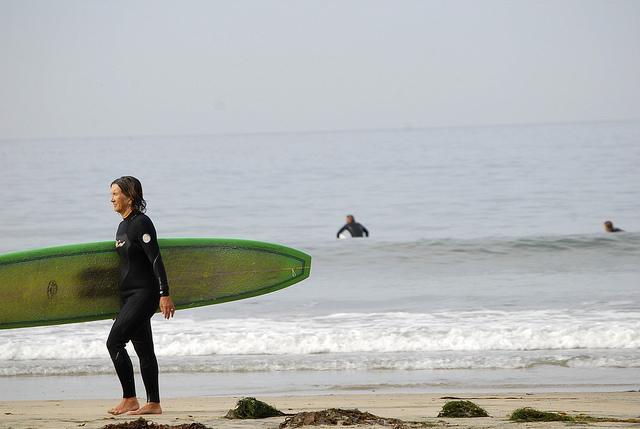Is he surfing right now?
Be succinct. No. Is the woman finished surfing?
Short answer required. Yes. Is the woman wearing shoes?
Concise answer only. No. How many surfers are shown?
Short answer required. 3. 